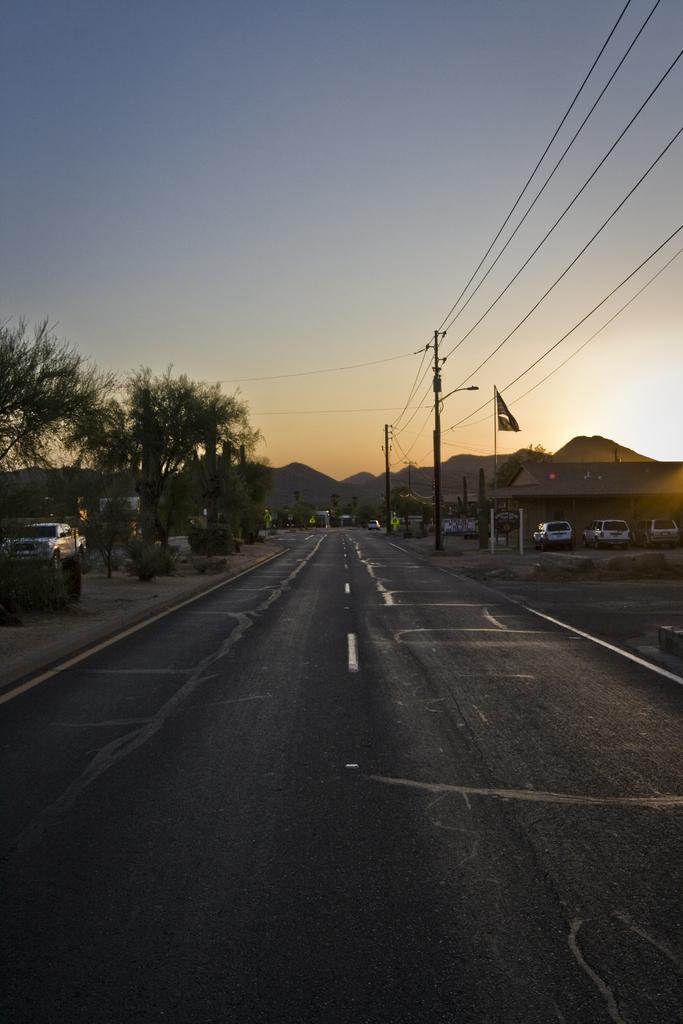Describe this image in one or two sentences. In this picture we can see vehicles. We can see transmission wires and poles. We can see trees, plants and the road. In the background we can see the sky and hills. 